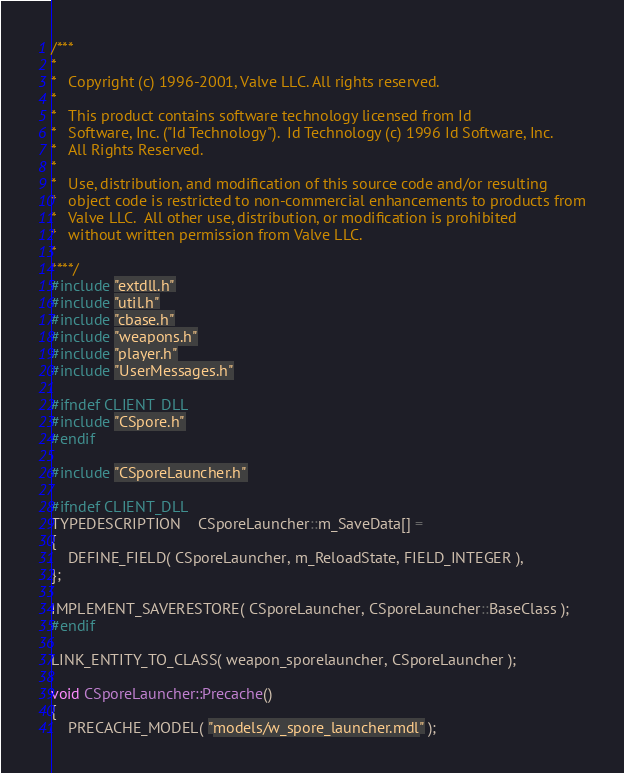<code> <loc_0><loc_0><loc_500><loc_500><_C++_>/***
*
*	Copyright (c) 1996-2001, Valve LLC. All rights reserved.
*
*	This product contains software technology licensed from Id
*	Software, Inc. ("Id Technology").  Id Technology (c) 1996 Id Software, Inc.
*	All Rights Reserved.
*
*   Use, distribution, and modification of this source code and/or resulting
*   object code is restricted to non-commercial enhancements to products from
*   Valve LLC.  All other use, distribution, or modification is prohibited
*   without written permission from Valve LLC.
*
****/
#include "extdll.h"
#include "util.h"
#include "cbase.h"
#include "weapons.h"
#include "player.h"
#include "UserMessages.h"

#ifndef CLIENT_DLL
#include "CSpore.h"
#endif

#include "CSporeLauncher.h"

#ifndef CLIENT_DLL
TYPEDESCRIPTION	CSporeLauncher::m_SaveData[] =
{
	DEFINE_FIELD( CSporeLauncher, m_ReloadState, FIELD_INTEGER ),
};

IMPLEMENT_SAVERESTORE( CSporeLauncher, CSporeLauncher::BaseClass );
#endif

LINK_ENTITY_TO_CLASS( weapon_sporelauncher, CSporeLauncher );

void CSporeLauncher::Precache()
{
	PRECACHE_MODEL( "models/w_spore_launcher.mdl" );</code> 